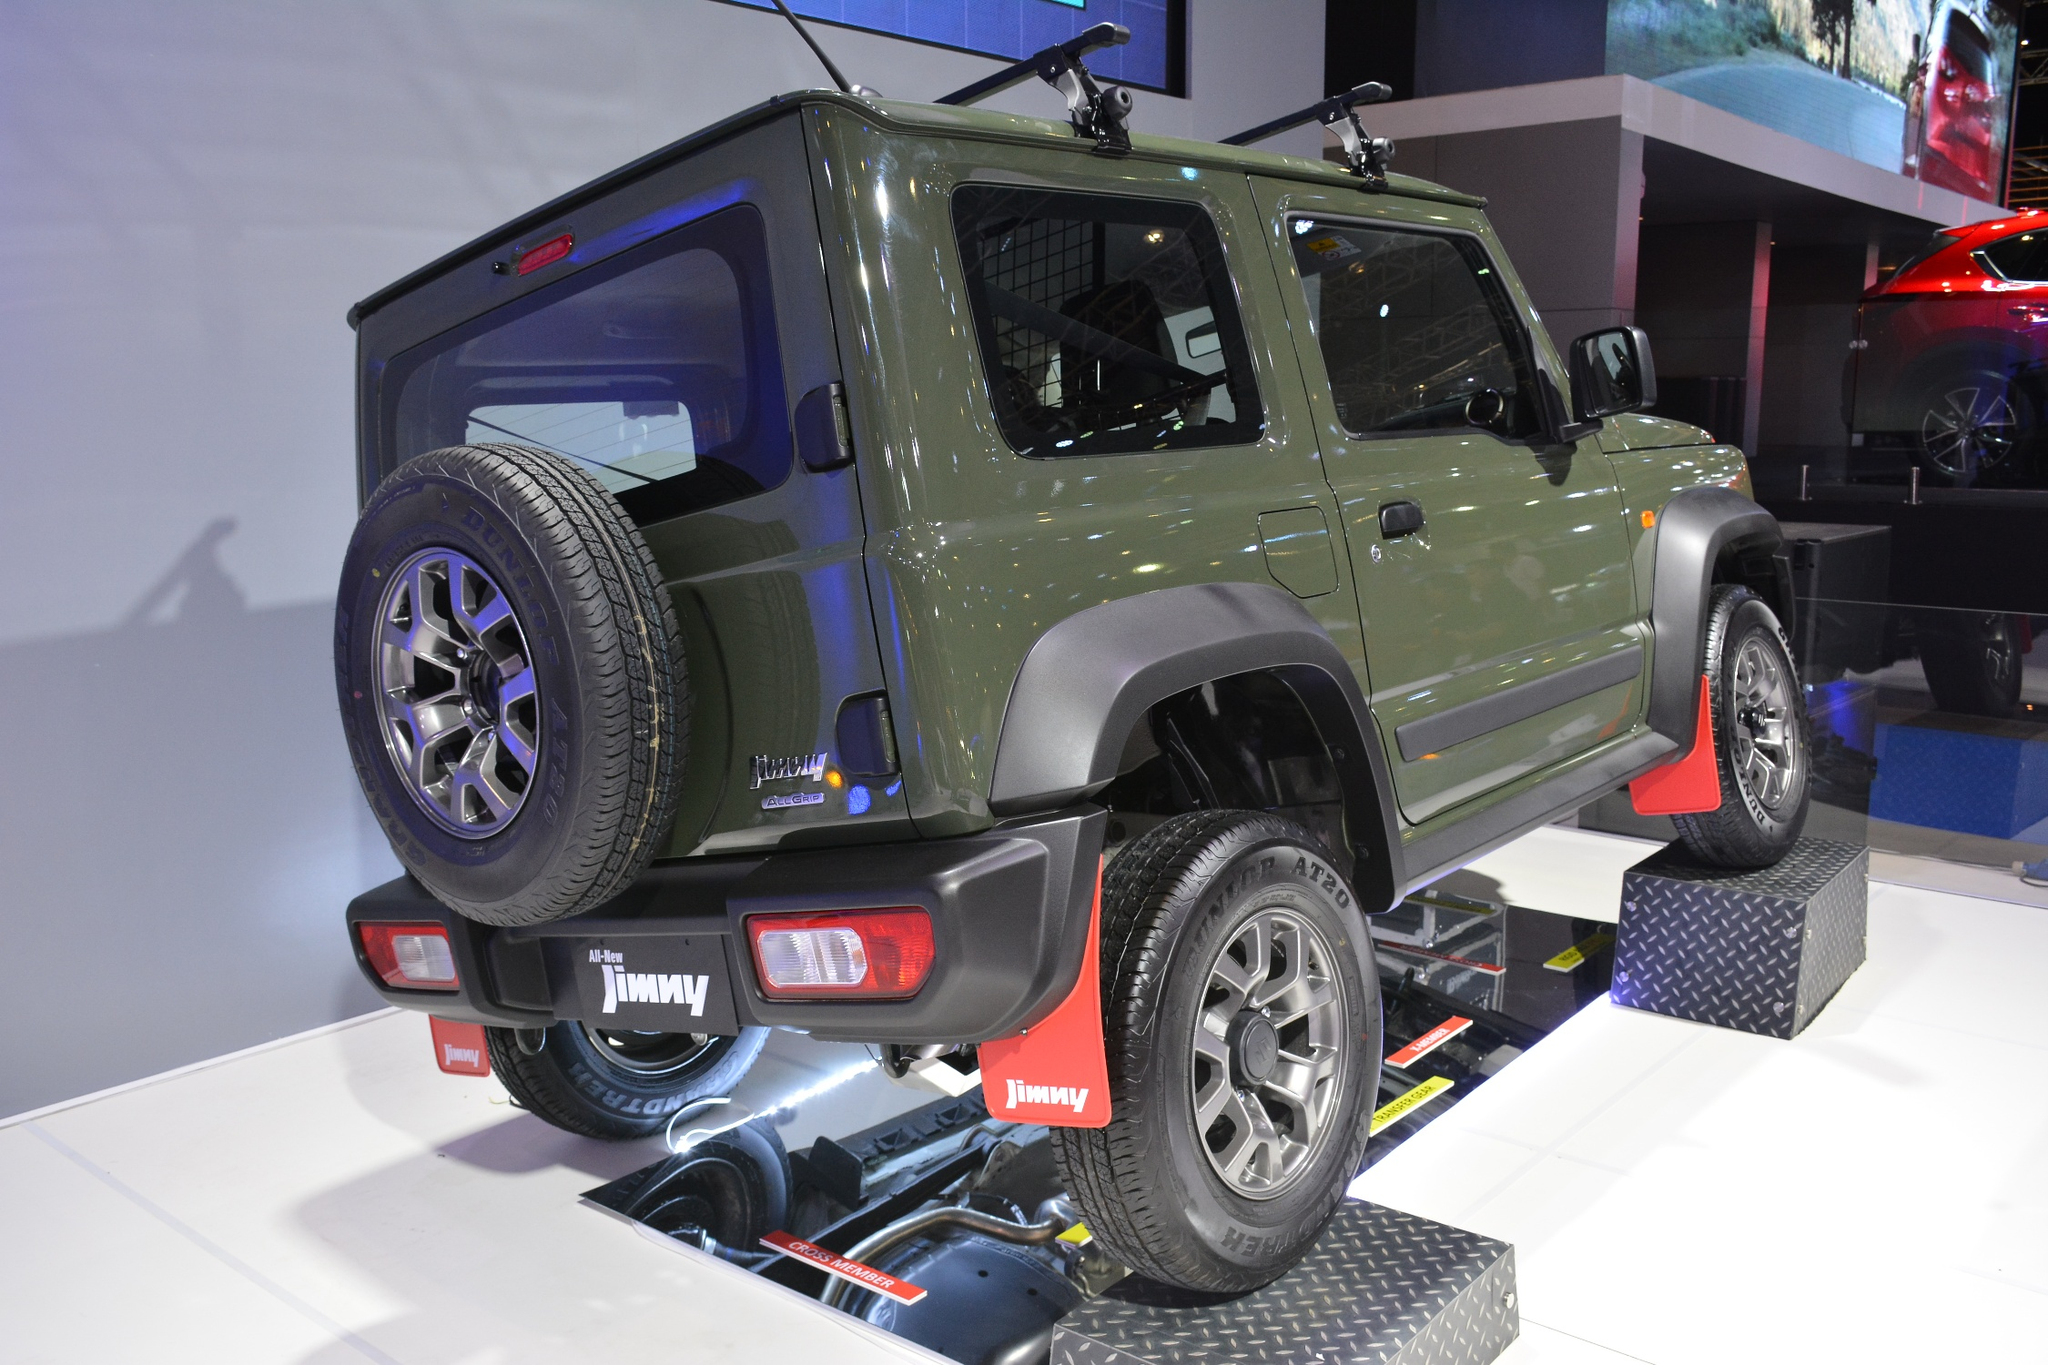Imagine this Suzuki Jimny could talk. What would it say about its features and capabilities? If the Suzuki Jimny could talk, it might say: 'Hello there! I'm the Suzuki Jimny, the perfect blend of tradition and modern capability. With my robust, boxy design, I'm built to handle any adventure you throw at me. Check out my spare tire securely mounted on my rear door—always ready for those off-road escapades. My roof rack with sturdy crossbars? Perfect for carrying extra gear for your outdoor adventures. But don't just look at my rugged exterior; step inside and you'll find a modern and comfortable interior designed to make your journey as enjoyable as the destination. Whether it's a weekend camping trip or a challenging trail, I'm ready to tackle it all with you!' 